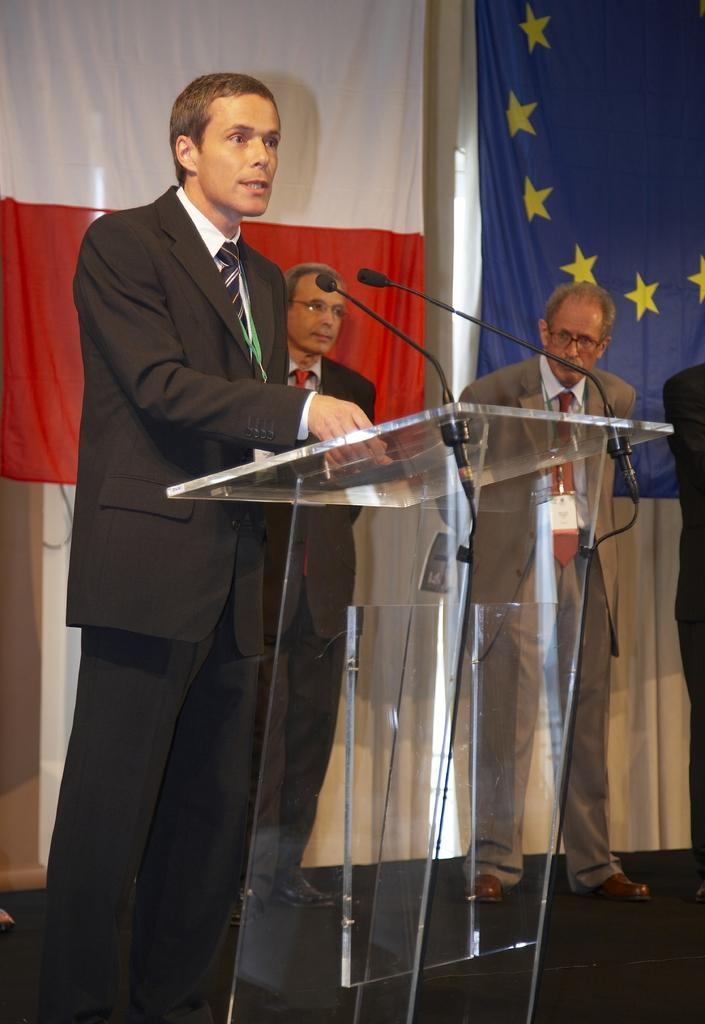What is the man in the image doing? The man is standing in front of a mic. What can be seen in the foreground of the image? There is a desk in the foreground area of the image. What is visible in the background of the image? There are people and flags in the background of the image. What type of bun is the scarecrow wearing in the image? There is no scarecrow or bun present in the image. 